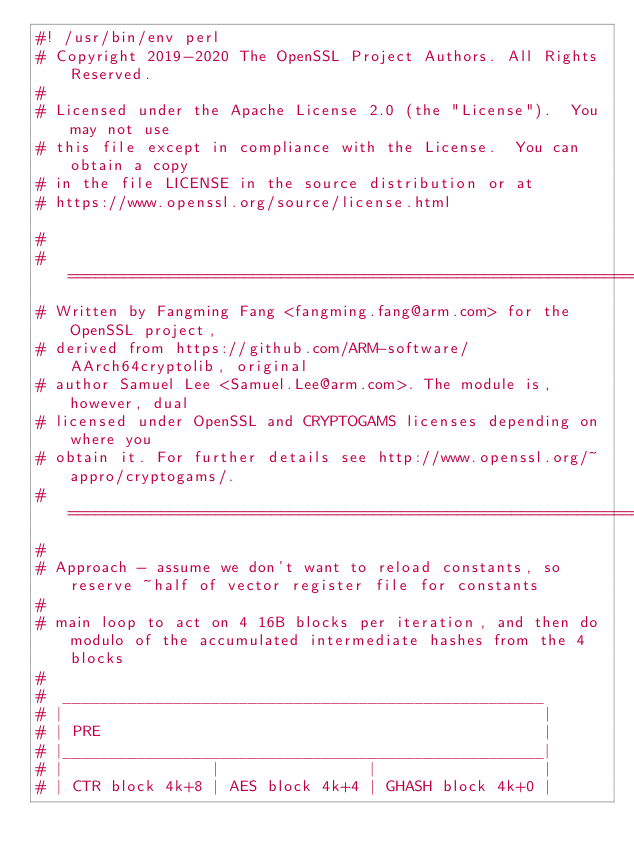<code> <loc_0><loc_0><loc_500><loc_500><_Perl_>#! /usr/bin/env perl
# Copyright 2019-2020 The OpenSSL Project Authors. All Rights Reserved.
#
# Licensed under the Apache License 2.0 (the "License").  You may not use
# this file except in compliance with the License.  You can obtain a copy
# in the file LICENSE in the source distribution or at
# https://www.openssl.org/source/license.html

#
#========================================================================
# Written by Fangming Fang <fangming.fang@arm.com> for the OpenSSL project,
# derived from https://github.com/ARM-software/AArch64cryptolib, original
# author Samuel Lee <Samuel.Lee@arm.com>. The module is, however, dual
# licensed under OpenSSL and CRYPTOGAMS licenses depending on where you
# obtain it. For further details see http://www.openssl.org/~appro/cryptogams/.
#========================================================================
#
# Approach - assume we don't want to reload constants, so reserve ~half of vector register file for constants
#
# main loop to act on 4 16B blocks per iteration, and then do modulo of the accumulated intermediate hashes from the 4 blocks
#
#  ____________________________________________________
# |                                                    |
# | PRE                                                |
# |____________________________________________________|
# |                |                |                  |
# | CTR block 4k+8 | AES block 4k+4 | GHASH block 4k+0 |</code> 